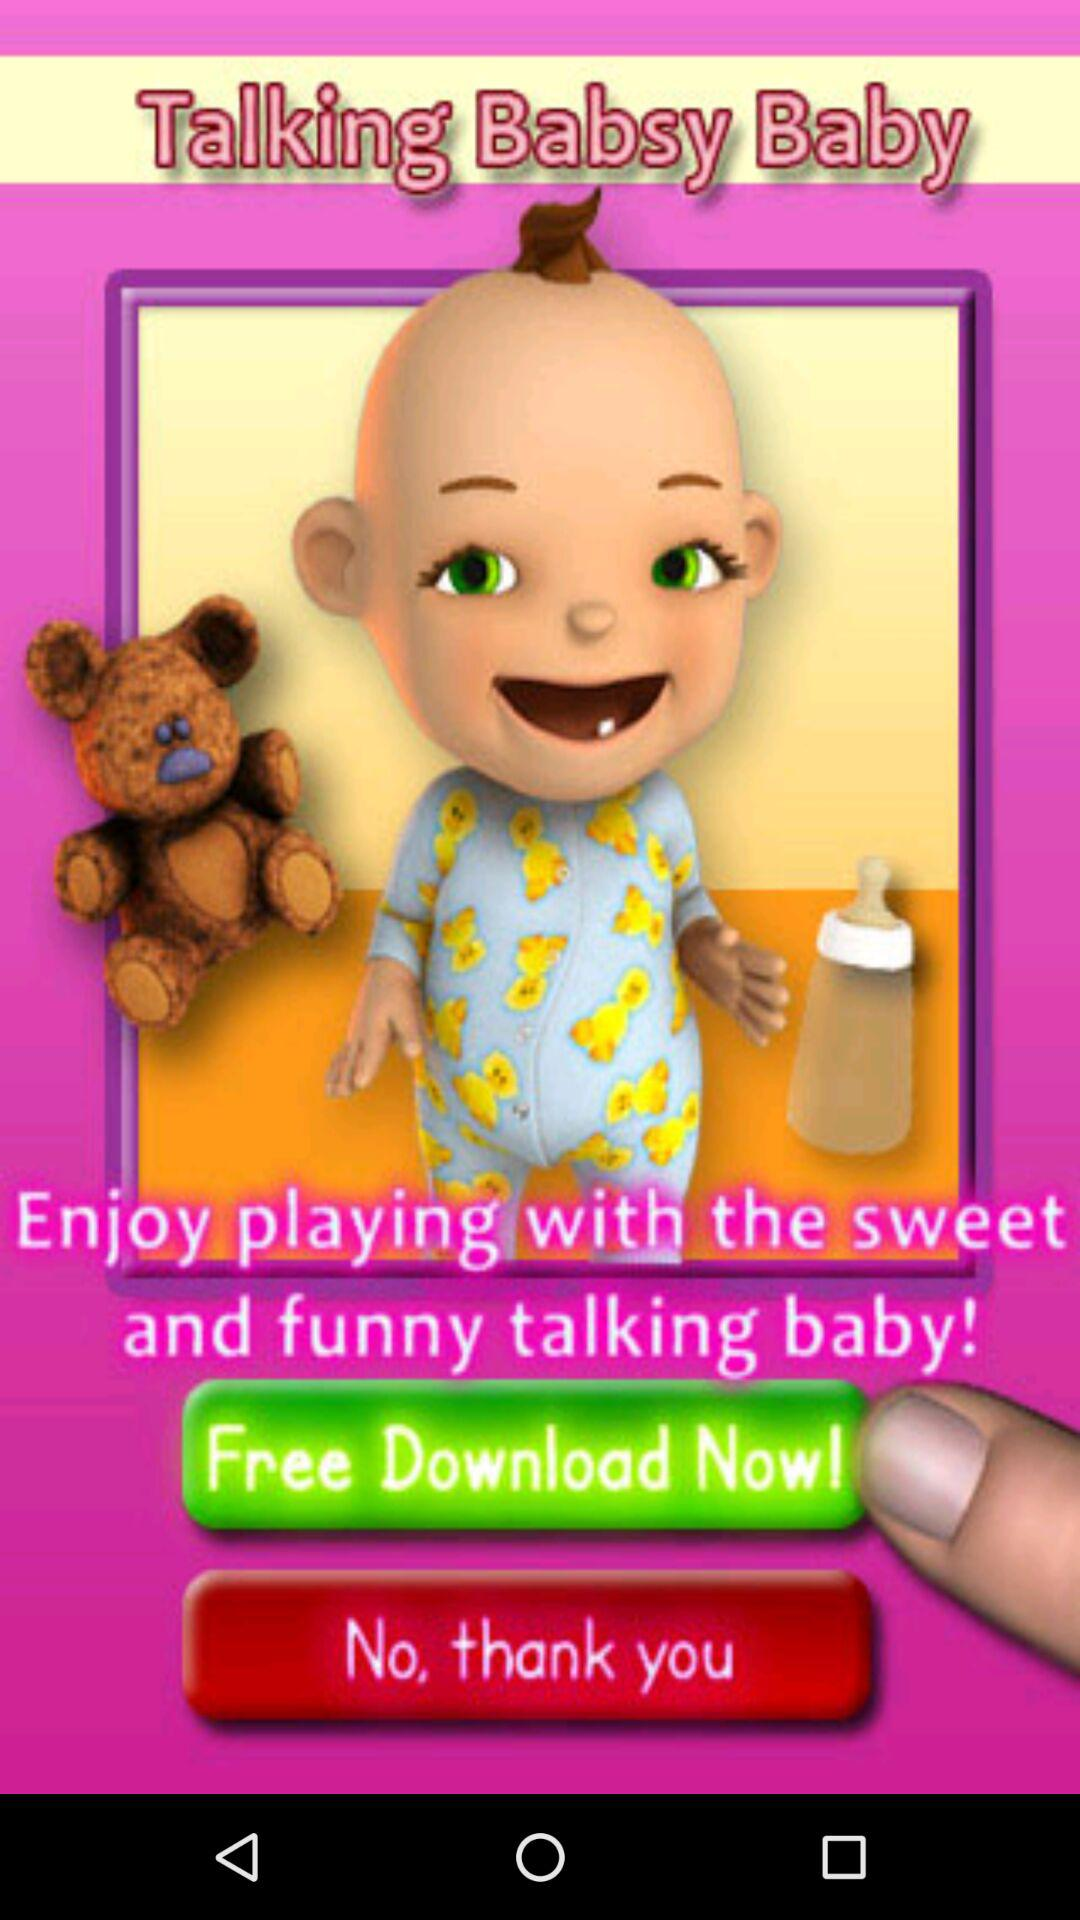Who developed the "Talking Babsy Baby" app?
When the provided information is insufficient, respond with <no answer>. <no answer> 